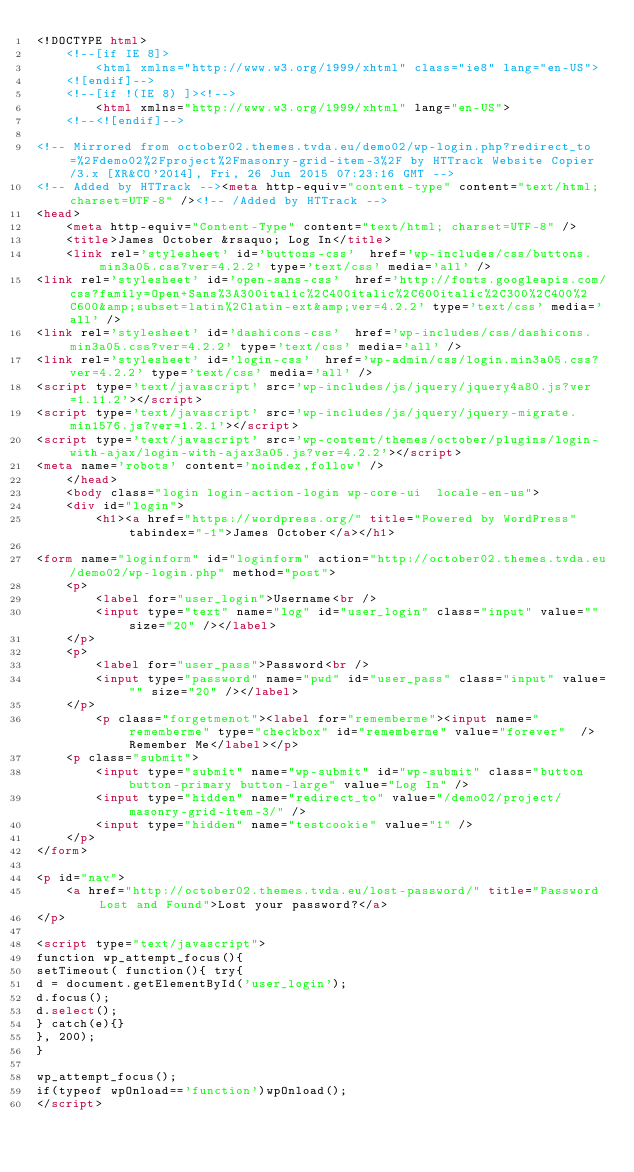<code> <loc_0><loc_0><loc_500><loc_500><_HTML_><!DOCTYPE html>
	<!--[if IE 8]>
		<html xmlns="http://www.w3.org/1999/xhtml" class="ie8" lang="en-US">
	<![endif]-->
	<!--[if !(IE 8) ]><!-->
		<html xmlns="http://www.w3.org/1999/xhtml" lang="en-US">
	<!--<![endif]-->
	
<!-- Mirrored from october02.themes.tvda.eu/demo02/wp-login.php?redirect_to=%2Fdemo02%2Fproject%2Fmasonry-grid-item-3%2F by HTTrack Website Copier/3.x [XR&CO'2014], Fri, 26 Jun 2015 07:23:16 GMT -->
<!-- Added by HTTrack --><meta http-equiv="content-type" content="text/html;charset=UTF-8" /><!-- /Added by HTTrack -->
<head>
	<meta http-equiv="Content-Type" content="text/html; charset=UTF-8" />
	<title>James October &rsaquo; Log In</title>
	<link rel='stylesheet' id='buttons-css'  href='wp-includes/css/buttons.min3a05.css?ver=4.2.2' type='text/css' media='all' />
<link rel='stylesheet' id='open-sans-css'  href='http://fonts.googleapis.com/css?family=Open+Sans%3A300italic%2C400italic%2C600italic%2C300%2C400%2C600&amp;subset=latin%2Clatin-ext&amp;ver=4.2.2' type='text/css' media='all' />
<link rel='stylesheet' id='dashicons-css'  href='wp-includes/css/dashicons.min3a05.css?ver=4.2.2' type='text/css' media='all' />
<link rel='stylesheet' id='login-css'  href='wp-admin/css/login.min3a05.css?ver=4.2.2' type='text/css' media='all' />
<script type='text/javascript' src='wp-includes/js/jquery/jquery4a80.js?ver=1.11.2'></script>
<script type='text/javascript' src='wp-includes/js/jquery/jquery-migrate.min1576.js?ver=1.2.1'></script>
<script type='text/javascript' src='wp-content/themes/october/plugins/login-with-ajax/login-with-ajax3a05.js?ver=4.2.2'></script>
<meta name='robots' content='noindex,follow' />
	</head>
	<body class="login login-action-login wp-core-ui  locale-en-us">
	<div id="login">
		<h1><a href="https://wordpress.org/" title="Powered by WordPress" tabindex="-1">James October</a></h1>
	
<form name="loginform" id="loginform" action="http://october02.themes.tvda.eu/demo02/wp-login.php" method="post">
	<p>
		<label for="user_login">Username<br />
		<input type="text" name="log" id="user_login" class="input" value="" size="20" /></label>
	</p>
	<p>
		<label for="user_pass">Password<br />
		<input type="password" name="pwd" id="user_pass" class="input" value="" size="20" /></label>
	</p>
		<p class="forgetmenot"><label for="rememberme"><input name="rememberme" type="checkbox" id="rememberme" value="forever"  /> Remember Me</label></p>
	<p class="submit">
		<input type="submit" name="wp-submit" id="wp-submit" class="button button-primary button-large" value="Log In" />
		<input type="hidden" name="redirect_to" value="/demo02/project/masonry-grid-item-3/" />
		<input type="hidden" name="testcookie" value="1" />
	</p>
</form>

<p id="nav">
	<a href="http://october02.themes.tvda.eu/lost-password/" title="Password Lost and Found">Lost your password?</a>
</p>

<script type="text/javascript">
function wp_attempt_focus(){
setTimeout( function(){ try{
d = document.getElementById('user_login');
d.focus();
d.select();
} catch(e){}
}, 200);
}

wp_attempt_focus();
if(typeof wpOnload=='function')wpOnload();
</script>
</code> 